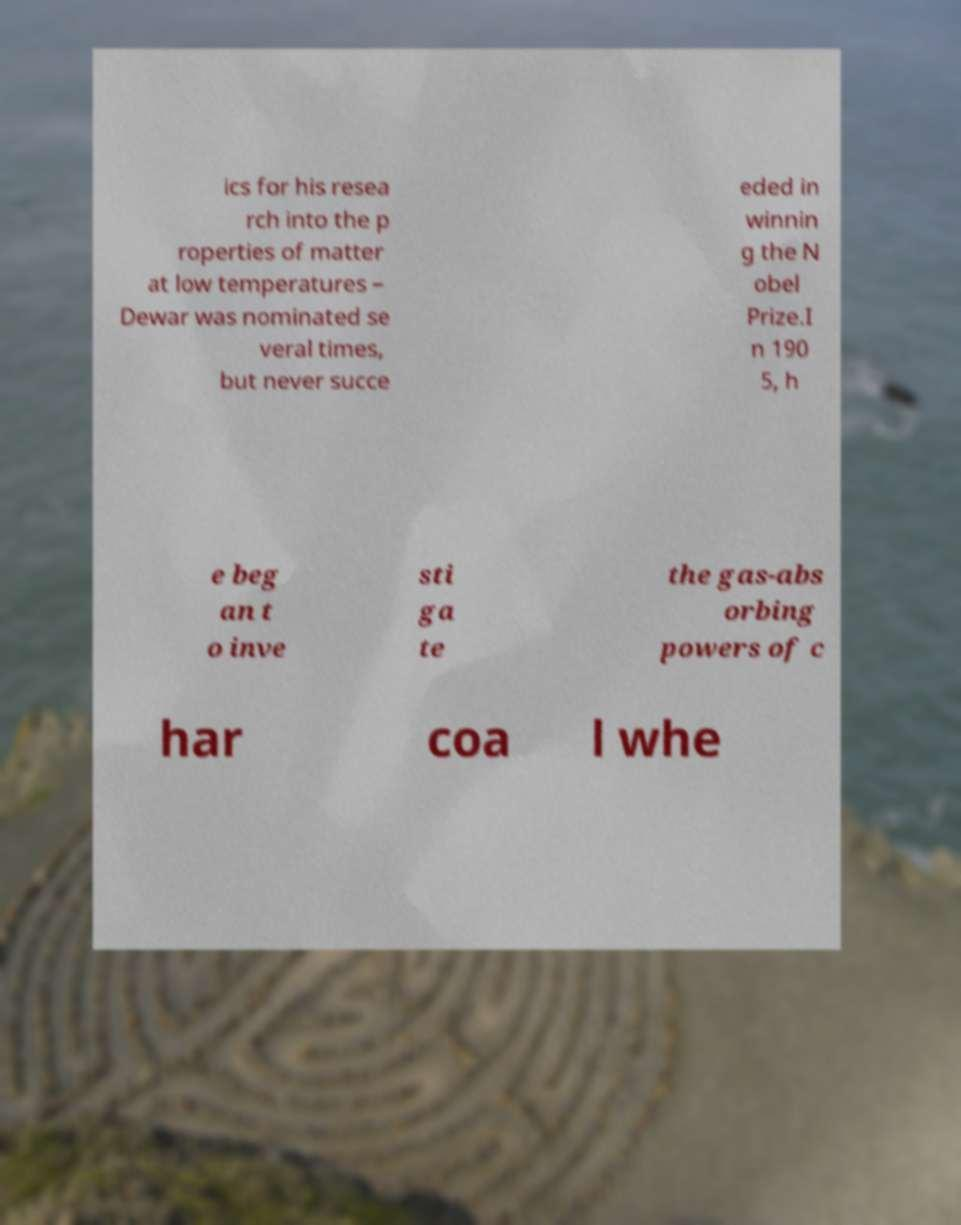I need the written content from this picture converted into text. Can you do that? ics for his resea rch into the p roperties of matter at low temperatures – Dewar was nominated se veral times, but never succe eded in winnin g the N obel Prize.I n 190 5, h e beg an t o inve sti ga te the gas-abs orbing powers of c har coa l whe 